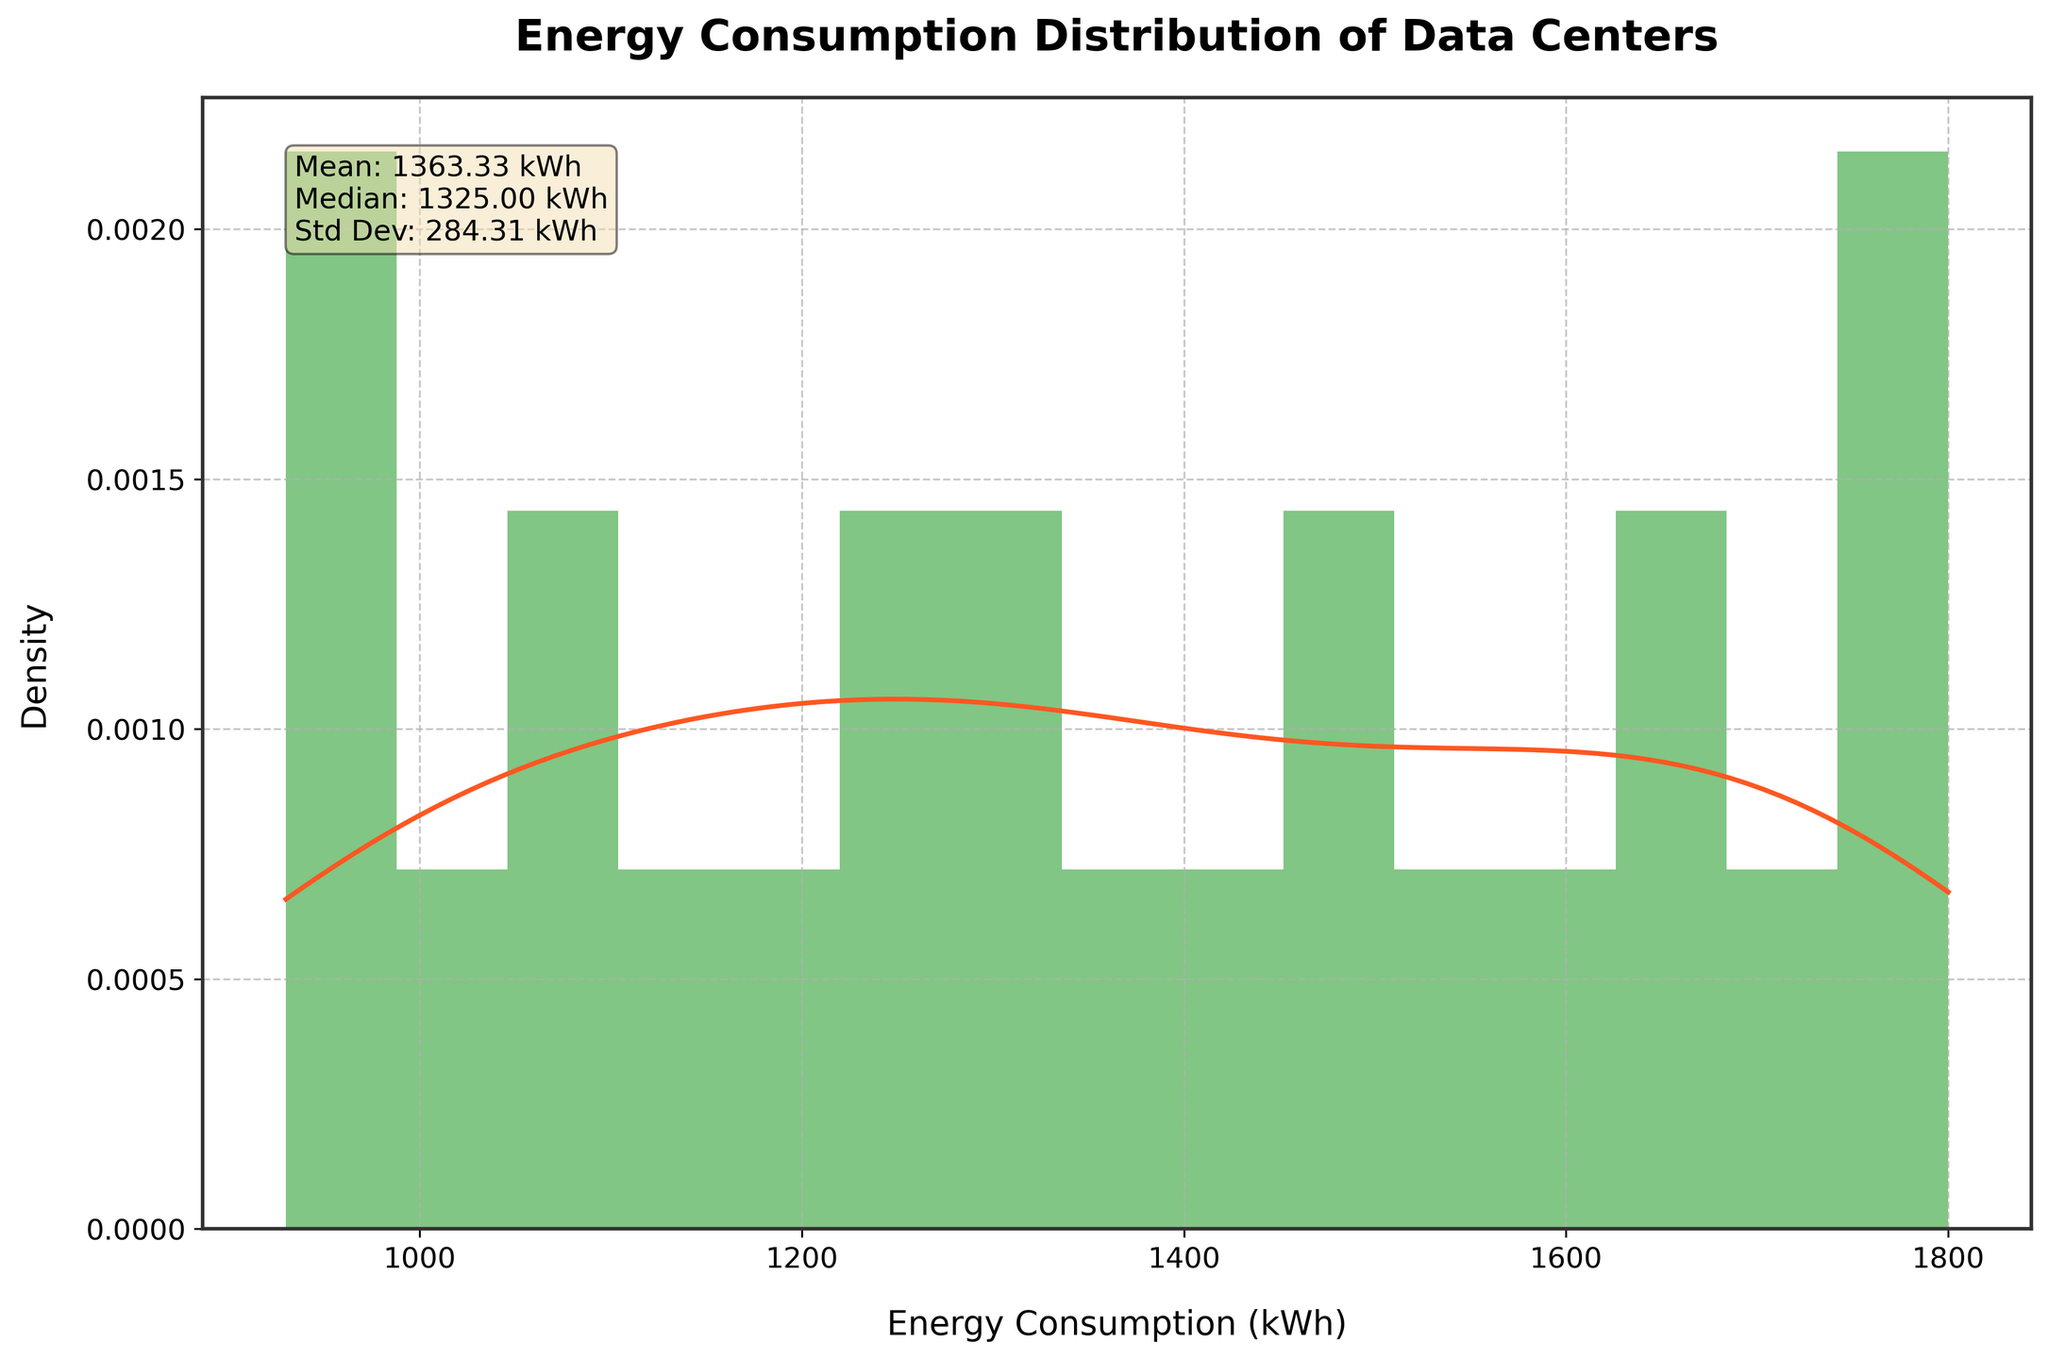What is the title of the histogram? The title is located at the top of the histogram. It reads "Energy Consumption Distribution of Data Centers".
Answer: Energy Consumption Distribution of Data Centers What color is the KDE (density curve)? The color of the KDE line is different from the histogram bars. It is red in color.
Answer: Red How many bins are there in the histogram? The histogram shows the distribution of energy consumption in bins, which are vertical bars. Counting the bars, one can see there are 15 bins.
Answer: 15 What is the mean value of the energy consumption? The mean value is provided in the text box inside the plot, which includes statistical data about the distribution.
Answer: 1389.17 kWh At what time is the highest energy consumption observed? By reviewing the data and considering the title and axis labels, one can deduce that 12:00 has the highest energy consumption.
Answer: 12:00 Which has a higher density: 1500 kWh or 1000 kWh? By observing the KDE curve, one can see that around 1500 kWh the density is higher compared to around 1000 kWh.
Answer: 1500 kWh What is the median energy consumption? The median is provided in the text box located within the plot. It states the median as 1500 kWh.
Answer: 1500 kWh Is the distribution of energy consumption approximately symmetric or skewed? Observing the histogram and KDE curve, the distribution has a longer tail on the left, suggesting that it is left-skewed.
Answer: Left-skewed How much higher is the peak density compared to the area around 1000 kWh? By comparing the peak point of the KDE curve against the KDE value at around 1000 kWh, one can see that the peak density is significantly higher.
Answer: Significantly higher Is there a notable drop in energy consumption during the early morning hours? Reviewing the plot and the reference to the times, the data shows a significant drop in energy consumption from midnight to about 06:00 AM.
Answer: Yes 